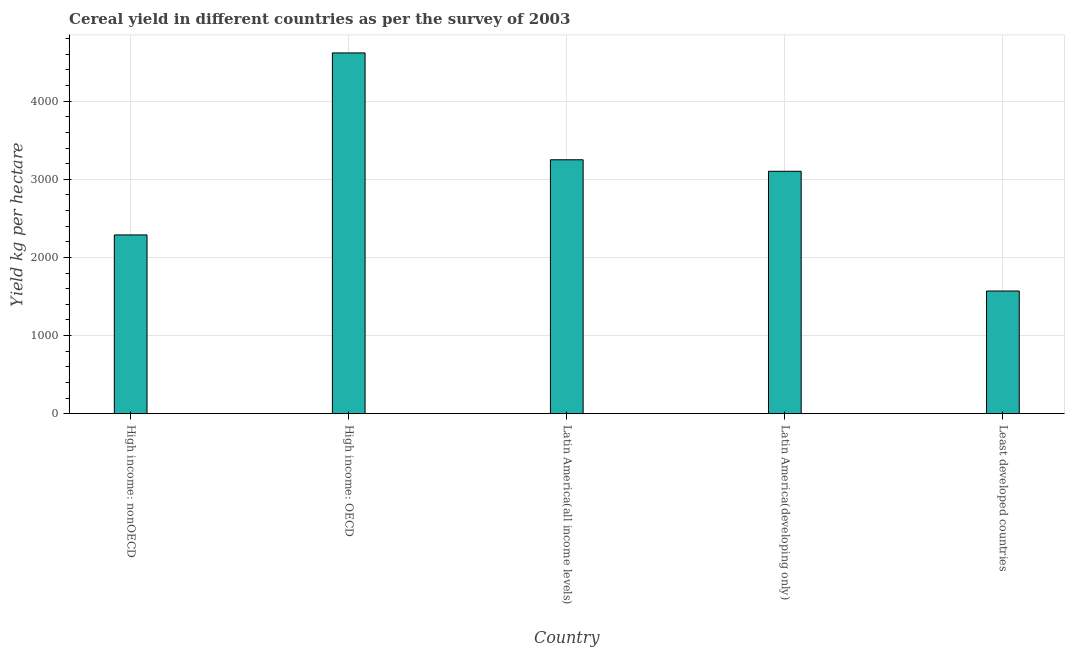What is the title of the graph?
Keep it short and to the point. Cereal yield in different countries as per the survey of 2003. What is the label or title of the Y-axis?
Keep it short and to the point. Yield kg per hectare. What is the cereal yield in Latin America(all income levels)?
Keep it short and to the point. 3249.58. Across all countries, what is the maximum cereal yield?
Provide a short and direct response. 4616.89. Across all countries, what is the minimum cereal yield?
Your answer should be compact. 1570.34. In which country was the cereal yield maximum?
Keep it short and to the point. High income: OECD. In which country was the cereal yield minimum?
Provide a short and direct response. Least developed countries. What is the sum of the cereal yield?
Make the answer very short. 1.48e+04. What is the difference between the cereal yield in Latin America(all income levels) and Latin America(developing only)?
Your response must be concise. 147.31. What is the average cereal yield per country?
Ensure brevity in your answer.  2965.43. What is the median cereal yield?
Offer a very short reply. 3102.27. In how many countries, is the cereal yield greater than 3200 kg per hectare?
Ensure brevity in your answer.  2. What is the ratio of the cereal yield in Latin America(all income levels) to that in Latin America(developing only)?
Your answer should be very brief. 1.05. What is the difference between the highest and the second highest cereal yield?
Give a very brief answer. 1367.31. Is the sum of the cereal yield in High income: OECD and Latin America(developing only) greater than the maximum cereal yield across all countries?
Offer a terse response. Yes. What is the difference between the highest and the lowest cereal yield?
Your answer should be compact. 3046.55. Are all the bars in the graph horizontal?
Provide a short and direct response. No. How many countries are there in the graph?
Keep it short and to the point. 5. What is the difference between two consecutive major ticks on the Y-axis?
Make the answer very short. 1000. Are the values on the major ticks of Y-axis written in scientific E-notation?
Give a very brief answer. No. What is the Yield kg per hectare of High income: nonOECD?
Your response must be concise. 2288.04. What is the Yield kg per hectare in High income: OECD?
Provide a succinct answer. 4616.89. What is the Yield kg per hectare in Latin America(all income levels)?
Provide a short and direct response. 3249.58. What is the Yield kg per hectare in Latin America(developing only)?
Give a very brief answer. 3102.27. What is the Yield kg per hectare in Least developed countries?
Your answer should be very brief. 1570.34. What is the difference between the Yield kg per hectare in High income: nonOECD and High income: OECD?
Your answer should be compact. -2328.84. What is the difference between the Yield kg per hectare in High income: nonOECD and Latin America(all income levels)?
Your answer should be very brief. -961.54. What is the difference between the Yield kg per hectare in High income: nonOECD and Latin America(developing only)?
Offer a terse response. -814.23. What is the difference between the Yield kg per hectare in High income: nonOECD and Least developed countries?
Your answer should be compact. 717.7. What is the difference between the Yield kg per hectare in High income: OECD and Latin America(all income levels)?
Make the answer very short. 1367.31. What is the difference between the Yield kg per hectare in High income: OECD and Latin America(developing only)?
Make the answer very short. 1514.61. What is the difference between the Yield kg per hectare in High income: OECD and Least developed countries?
Your answer should be very brief. 3046.55. What is the difference between the Yield kg per hectare in Latin America(all income levels) and Latin America(developing only)?
Keep it short and to the point. 147.31. What is the difference between the Yield kg per hectare in Latin America(all income levels) and Least developed countries?
Provide a short and direct response. 1679.24. What is the difference between the Yield kg per hectare in Latin America(developing only) and Least developed countries?
Keep it short and to the point. 1531.93. What is the ratio of the Yield kg per hectare in High income: nonOECD to that in High income: OECD?
Keep it short and to the point. 0.5. What is the ratio of the Yield kg per hectare in High income: nonOECD to that in Latin America(all income levels)?
Keep it short and to the point. 0.7. What is the ratio of the Yield kg per hectare in High income: nonOECD to that in Latin America(developing only)?
Ensure brevity in your answer.  0.74. What is the ratio of the Yield kg per hectare in High income: nonOECD to that in Least developed countries?
Provide a succinct answer. 1.46. What is the ratio of the Yield kg per hectare in High income: OECD to that in Latin America(all income levels)?
Offer a very short reply. 1.42. What is the ratio of the Yield kg per hectare in High income: OECD to that in Latin America(developing only)?
Give a very brief answer. 1.49. What is the ratio of the Yield kg per hectare in High income: OECD to that in Least developed countries?
Keep it short and to the point. 2.94. What is the ratio of the Yield kg per hectare in Latin America(all income levels) to that in Latin America(developing only)?
Your answer should be very brief. 1.05. What is the ratio of the Yield kg per hectare in Latin America(all income levels) to that in Least developed countries?
Give a very brief answer. 2.07. What is the ratio of the Yield kg per hectare in Latin America(developing only) to that in Least developed countries?
Your response must be concise. 1.98. 